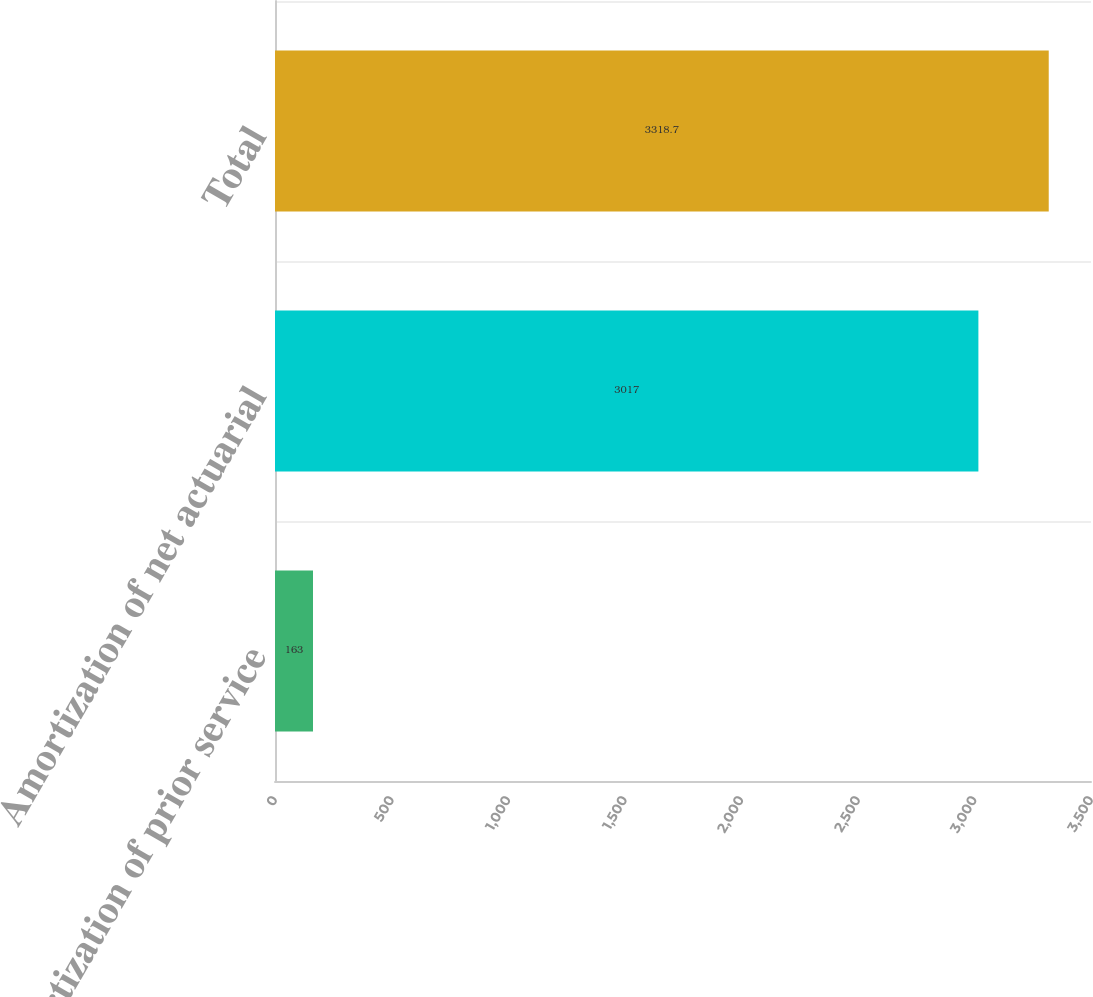<chart> <loc_0><loc_0><loc_500><loc_500><bar_chart><fcel>Amortization of prior service<fcel>Amortization of net actuarial<fcel>Total<nl><fcel>163<fcel>3017<fcel>3318.7<nl></chart> 